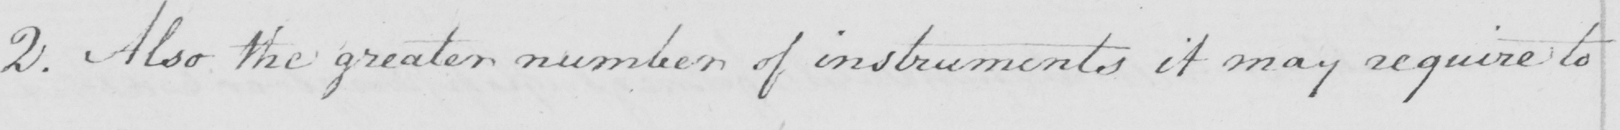What text is written in this handwritten line? 2 . Also the greater number of instruments it may require to 